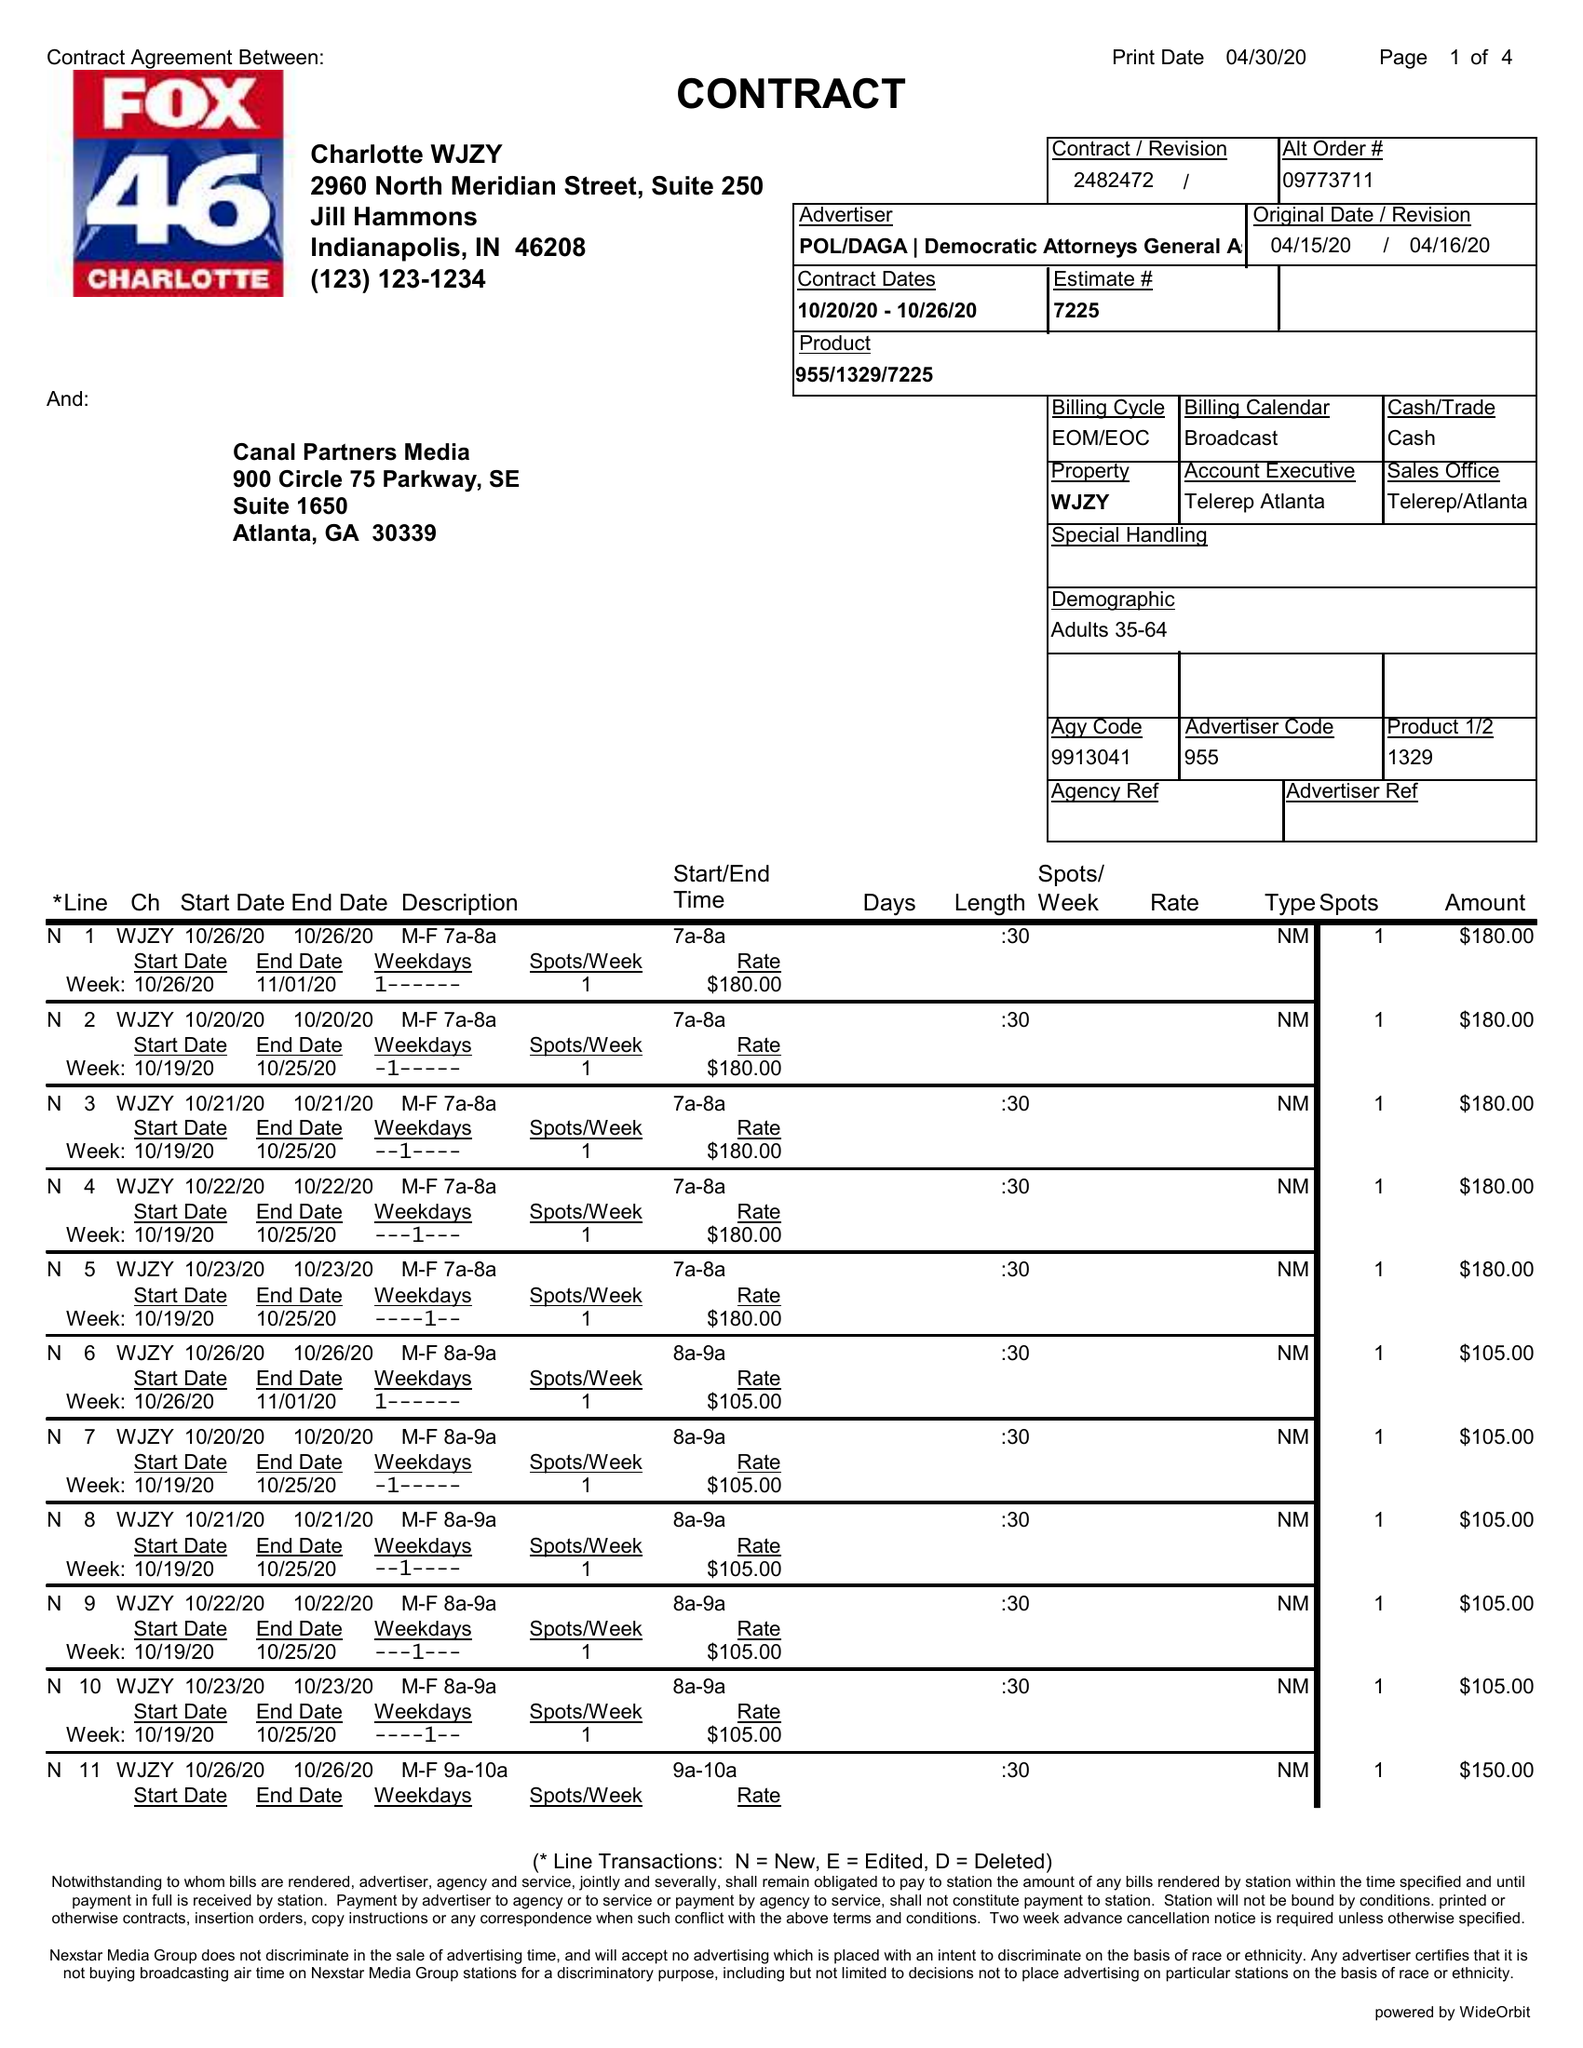What is the value for the gross_amount?
Answer the question using a single word or phrase. 7335.00 